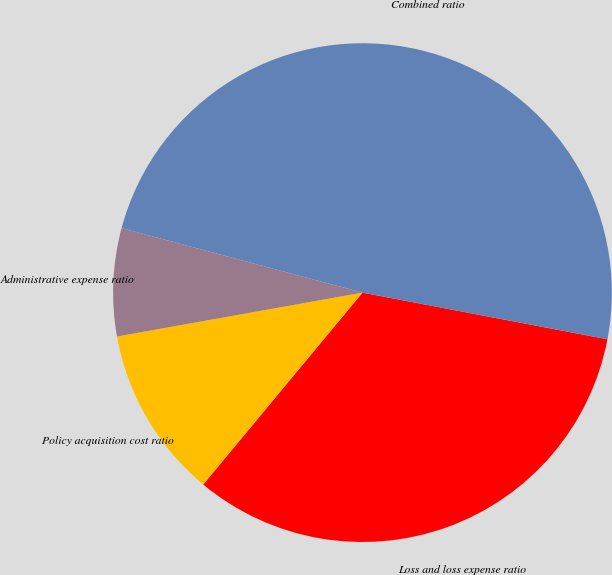Convert chart to OTSL. <chart><loc_0><loc_0><loc_500><loc_500><pie_chart><fcel>Loss and loss expense ratio<fcel>Policy acquisition cost ratio<fcel>Administrative expense ratio<fcel>Combined ratio<nl><fcel>33.03%<fcel>11.16%<fcel>6.98%<fcel>48.83%<nl></chart> 